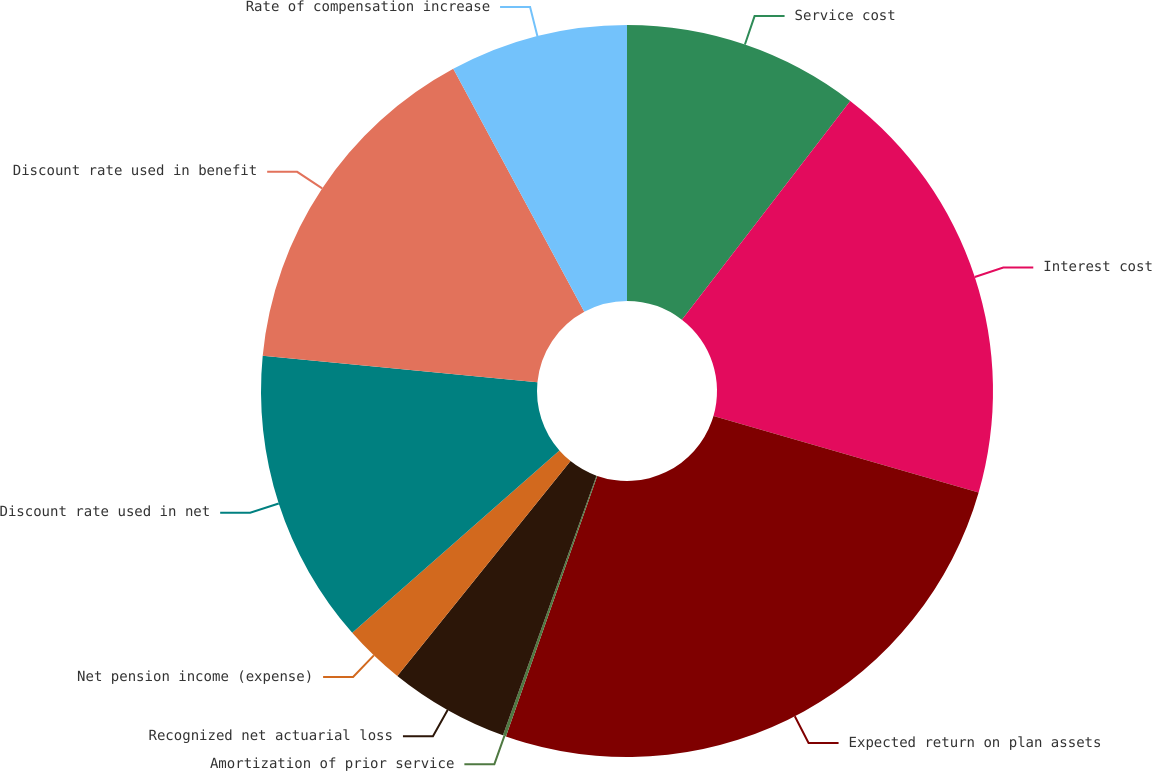Convert chart to OTSL. <chart><loc_0><loc_0><loc_500><loc_500><pie_chart><fcel>Service cost<fcel>Interest cost<fcel>Expected return on plan assets<fcel>Amortization of prior service<fcel>Recognized net actuarial loss<fcel>Net pension income (expense)<fcel>Discount rate used in net<fcel>Discount rate used in benefit<fcel>Rate of compensation increase<nl><fcel>10.44%<fcel>19.03%<fcel>25.89%<fcel>0.14%<fcel>5.29%<fcel>2.72%<fcel>13.02%<fcel>15.59%<fcel>7.87%<nl></chart> 